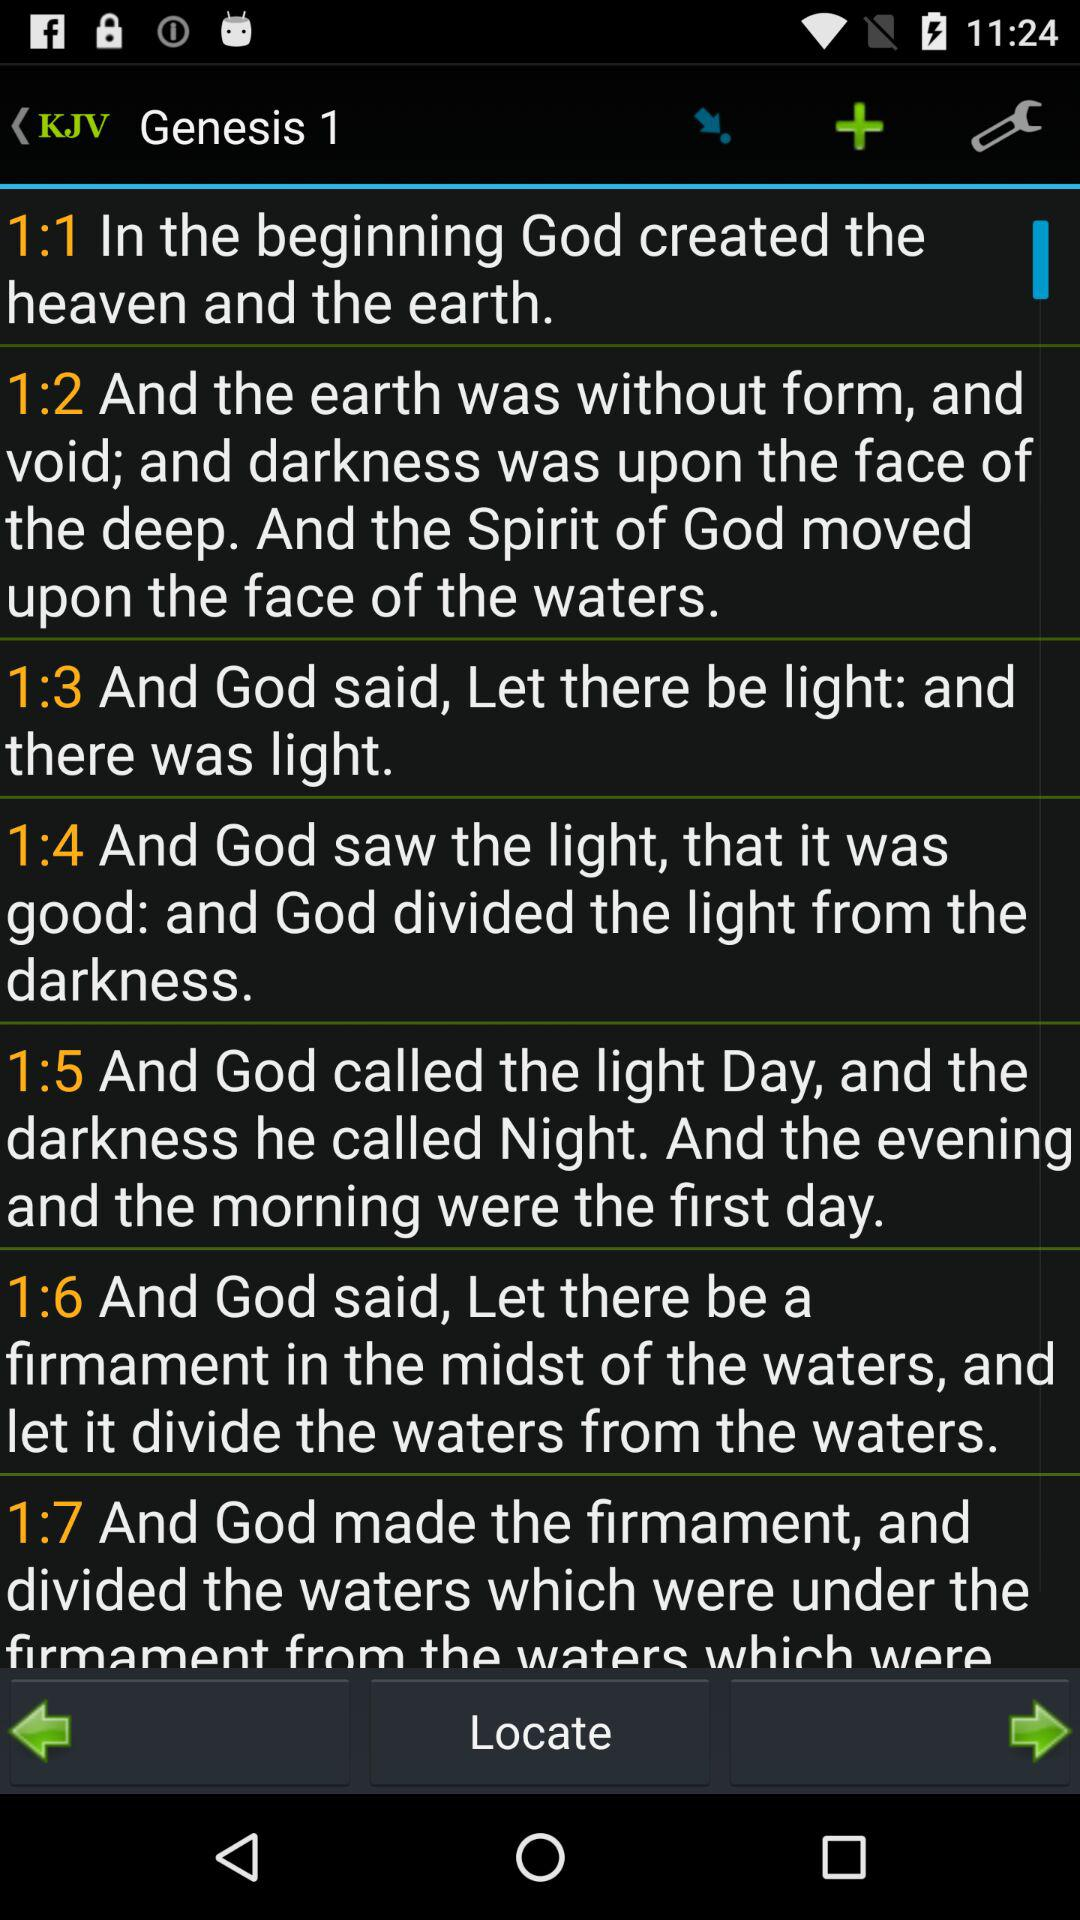What Genesis number is this? The Genesis number is 1. 